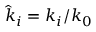Convert formula to latex. <formula><loc_0><loc_0><loc_500><loc_500>{ \hat { k } } _ { i } = k _ { i } / k _ { 0 }</formula> 